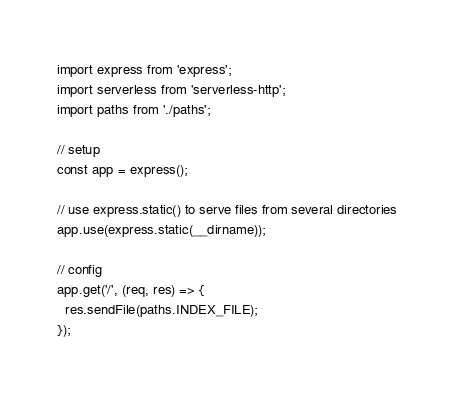Convert code to text. <code><loc_0><loc_0><loc_500><loc_500><_JavaScript_>import express from 'express';
import serverless from 'serverless-http';
import paths from './paths';

// setup
const app = express();

// use express.static() to serve files from several directories
app.use(express.static(__dirname));

// config
app.get('/', (req, res) => {
  res.sendFile(paths.INDEX_FILE);
});
</code> 